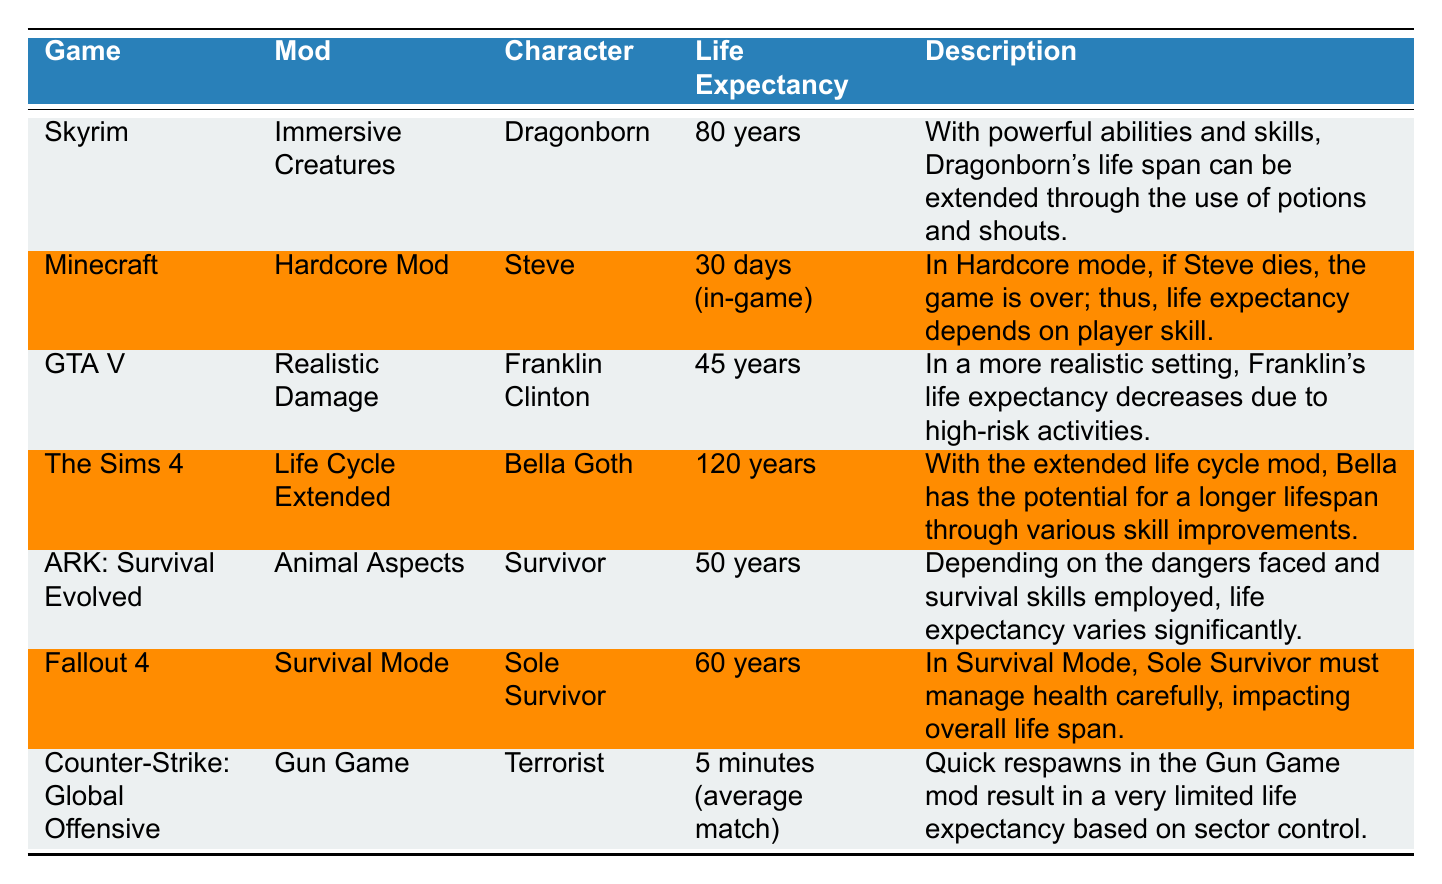What is the life expectancy of Bella Goth in The Sims 4? The table indicates that Bella Goth has a life expectancy of 120 years, which is explicitly stated in the corresponding row for The Sims 4 under the Life Cycle Extended mod.
Answer: 120 years Which character has the shortest life expectancy? The table shows that the character with the shortest life expectancy is the Terrorist in Counter-Strike: Global Offensive, with an average of 5 minutes per match, making this the lowest value listed.
Answer: 5 minutes (average match) What is the difference in life expectancy between the Dragonborn and the Sole Survivor? The Dragonborn has a life expectancy of 80 years, while the Sole Survivor has a life expectancy of 60 years. The difference can be calculated as 80 - 60 = 20 years, indicating that the Dragonborn lives 20 years longer.
Answer: 20 years Is the life expectancy of Steve higher than that of Franklin Clinton? Steve has a life expectancy of 30 days (in-game) in Minecraft, while Franklin Clinton's life expectancy is 45 years in GTA V. Since 30 days is significantly lower than 45 years, the answer to whether Steve has a higher life expectancy is no.
Answer: No What is the average life expectancy of characters in ARK: Survival Evolved and Fallout 4? In ARK: Survival Evolved, the Survivor has a life expectancy of 50 years, while in Fallout 4, the Sole Survivor has a life expectancy of 60 years. To find the average, we add both values (50 + 60) = 110 years, then divide by the number of characters (2). Therefore, the average is 110 / 2 = 55 years.
Answer: 55 years 